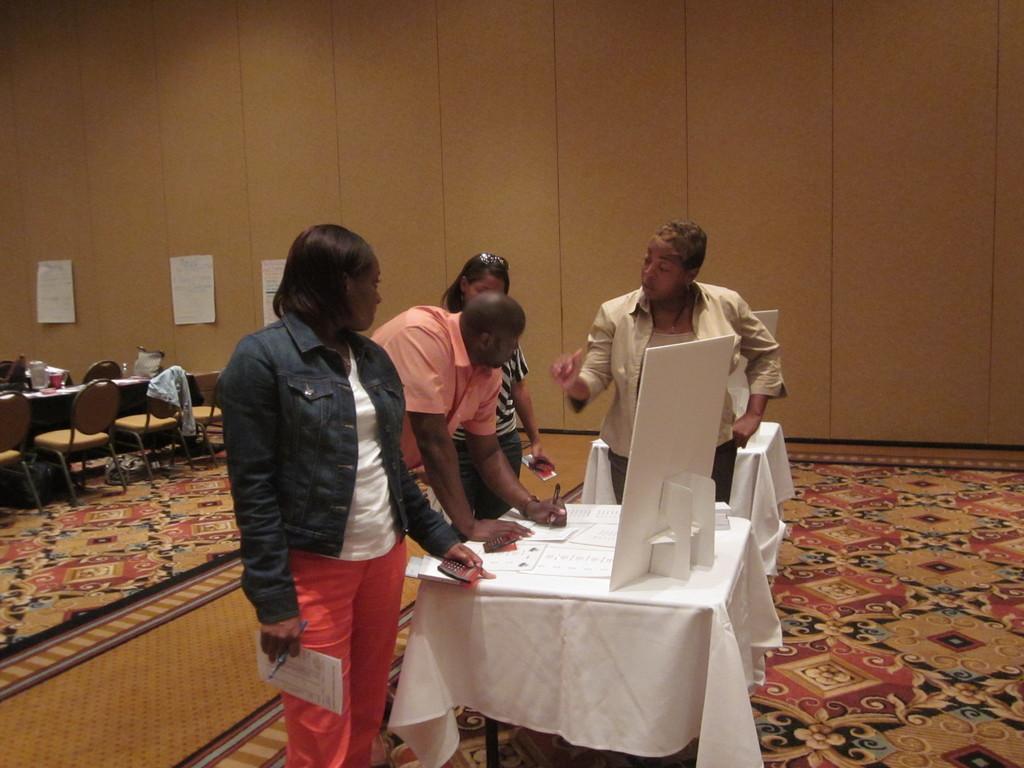Describe this image in one or two sentences. This image is clicked in a room. On the left side there are tables and chairs. In the middle there are tables on which there is monitor. There are four people standing around the table. On the table there are papers. There is a carpet in the bottom. There are papers pasted on the left side. 